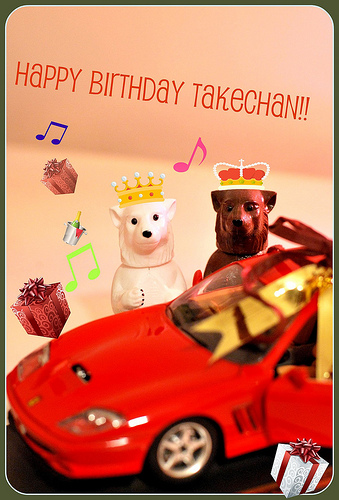<image>
Is the birthday on the wall? Yes. Looking at the image, I can see the birthday is positioned on top of the wall, with the wall providing support. Is there a car in front of the bear? Yes. The car is positioned in front of the bear, appearing closer to the camera viewpoint. Is the note in front of the dog? No. The note is not in front of the dog. The spatial positioning shows a different relationship between these objects. 